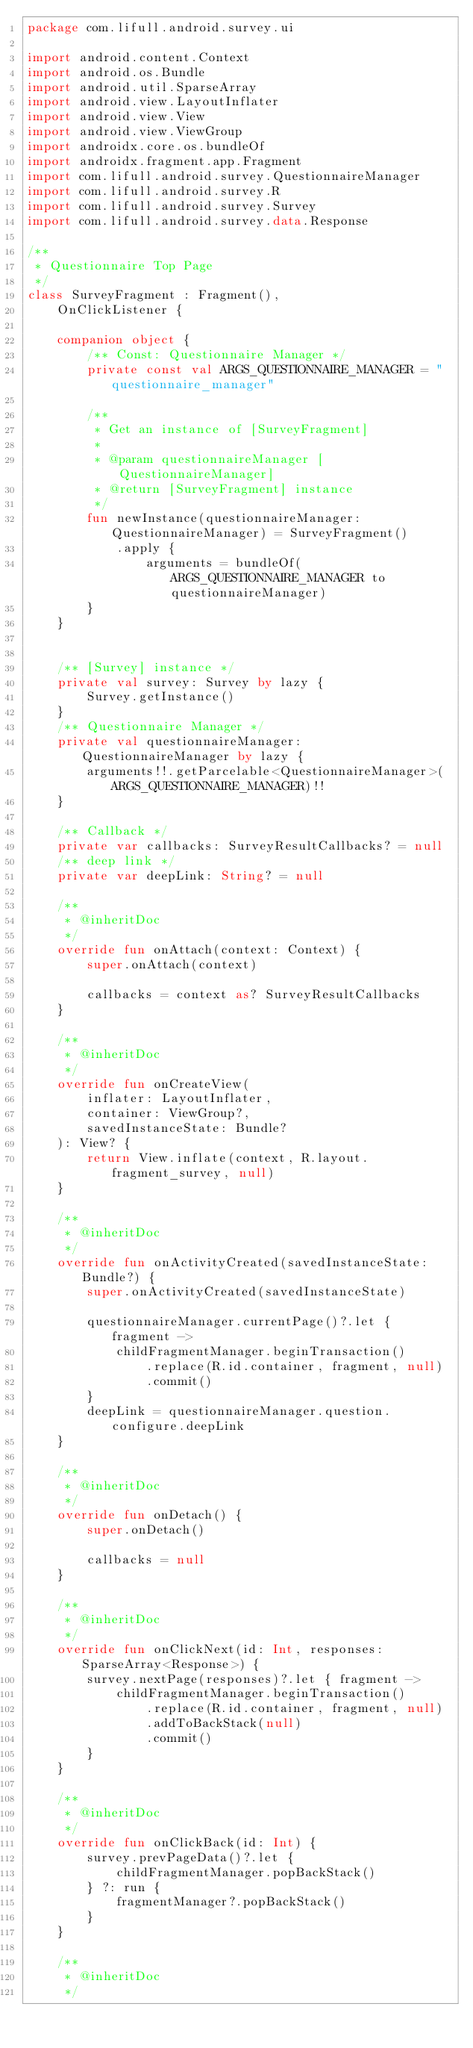<code> <loc_0><loc_0><loc_500><loc_500><_Kotlin_>package com.lifull.android.survey.ui

import android.content.Context
import android.os.Bundle
import android.util.SparseArray
import android.view.LayoutInflater
import android.view.View
import android.view.ViewGroup
import androidx.core.os.bundleOf
import androidx.fragment.app.Fragment
import com.lifull.android.survey.QuestionnaireManager
import com.lifull.android.survey.R
import com.lifull.android.survey.Survey
import com.lifull.android.survey.data.Response

/**
 * Questionnaire Top Page
 */
class SurveyFragment : Fragment(),
    OnClickListener {

    companion object {
        /** Const: Questionnaire Manager */
        private const val ARGS_QUESTIONNAIRE_MANAGER = "questionnaire_manager"

        /**
         * Get an instance of [SurveyFragment]
         *
         * @param questionnaireManager [QuestionnaireManager]
         * @return [SurveyFragment] instance
         */
        fun newInstance(questionnaireManager: QuestionnaireManager) = SurveyFragment()
            .apply {
                arguments = bundleOf(ARGS_QUESTIONNAIRE_MANAGER to questionnaireManager)
        }
    }


    /** [Survey] instance */
    private val survey: Survey by lazy {
        Survey.getInstance()
    }
    /** Questionnaire Manager */
    private val questionnaireManager: QuestionnaireManager by lazy {
        arguments!!.getParcelable<QuestionnaireManager>(ARGS_QUESTIONNAIRE_MANAGER)!!
    }

    /** Callback */
    private var callbacks: SurveyResultCallbacks? = null
    /** deep link */
    private var deepLink: String? = null

    /**
     * @inheritDoc
     */
    override fun onAttach(context: Context) {
        super.onAttach(context)

        callbacks = context as? SurveyResultCallbacks
    }

    /**
     * @inheritDoc
     */
    override fun onCreateView(
        inflater: LayoutInflater,
        container: ViewGroup?,
        savedInstanceState: Bundle?
    ): View? {
        return View.inflate(context, R.layout.fragment_survey, null)
    }

    /**
     * @inheritDoc
     */
    override fun onActivityCreated(savedInstanceState: Bundle?) {
        super.onActivityCreated(savedInstanceState)

        questionnaireManager.currentPage()?.let { fragment ->
            childFragmentManager.beginTransaction()
                .replace(R.id.container, fragment, null)
                .commit()
        }
        deepLink = questionnaireManager.question.configure.deepLink
    }

    /**
     * @inheritDoc
     */
    override fun onDetach() {
        super.onDetach()

        callbacks = null
    }

    /**
     * @inheritDoc
     */
    override fun onClickNext(id: Int, responses: SparseArray<Response>) {
        survey.nextPage(responses)?.let { fragment ->
            childFragmentManager.beginTransaction()
                .replace(R.id.container, fragment, null)
                .addToBackStack(null)
                .commit()
        }
    }

    /**
     * @inheritDoc
     */
    override fun onClickBack(id: Int) {
        survey.prevPageData()?.let {
            childFragmentManager.popBackStack()
        } ?: run {
            fragmentManager?.popBackStack()
        }
    }

    /**
     * @inheritDoc
     */</code> 